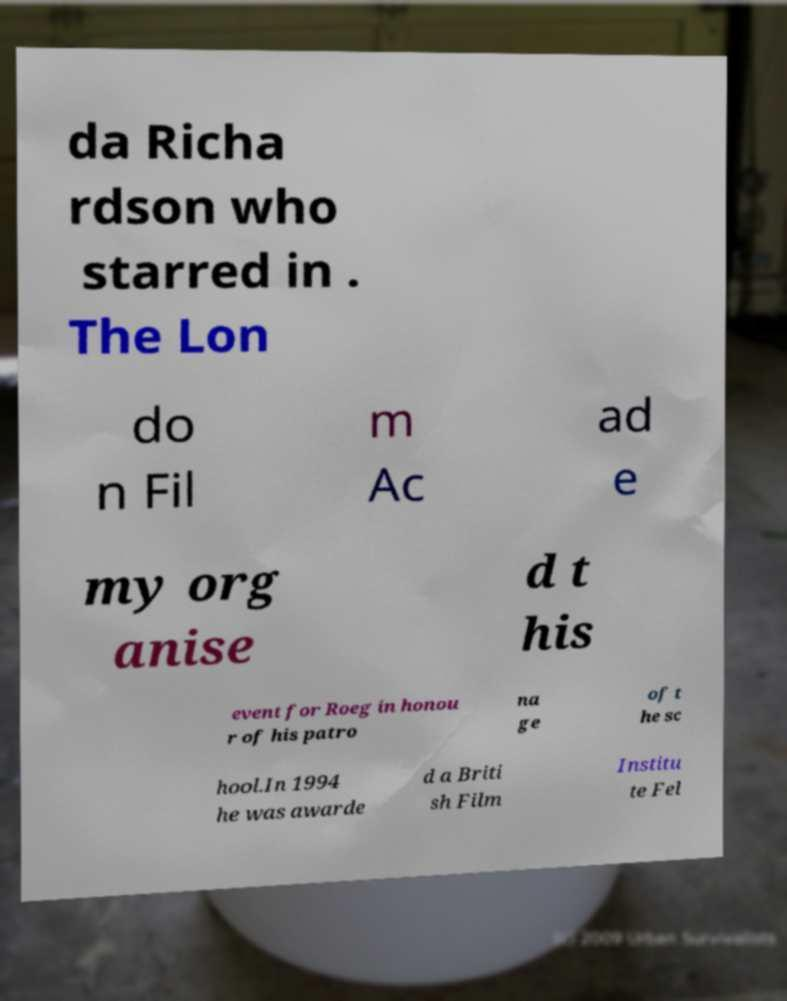Can you read and provide the text displayed in the image?This photo seems to have some interesting text. Can you extract and type it out for me? da Richa rdson who starred in . The Lon do n Fil m Ac ad e my org anise d t his event for Roeg in honou r of his patro na ge of t he sc hool.In 1994 he was awarde d a Briti sh Film Institu te Fel 